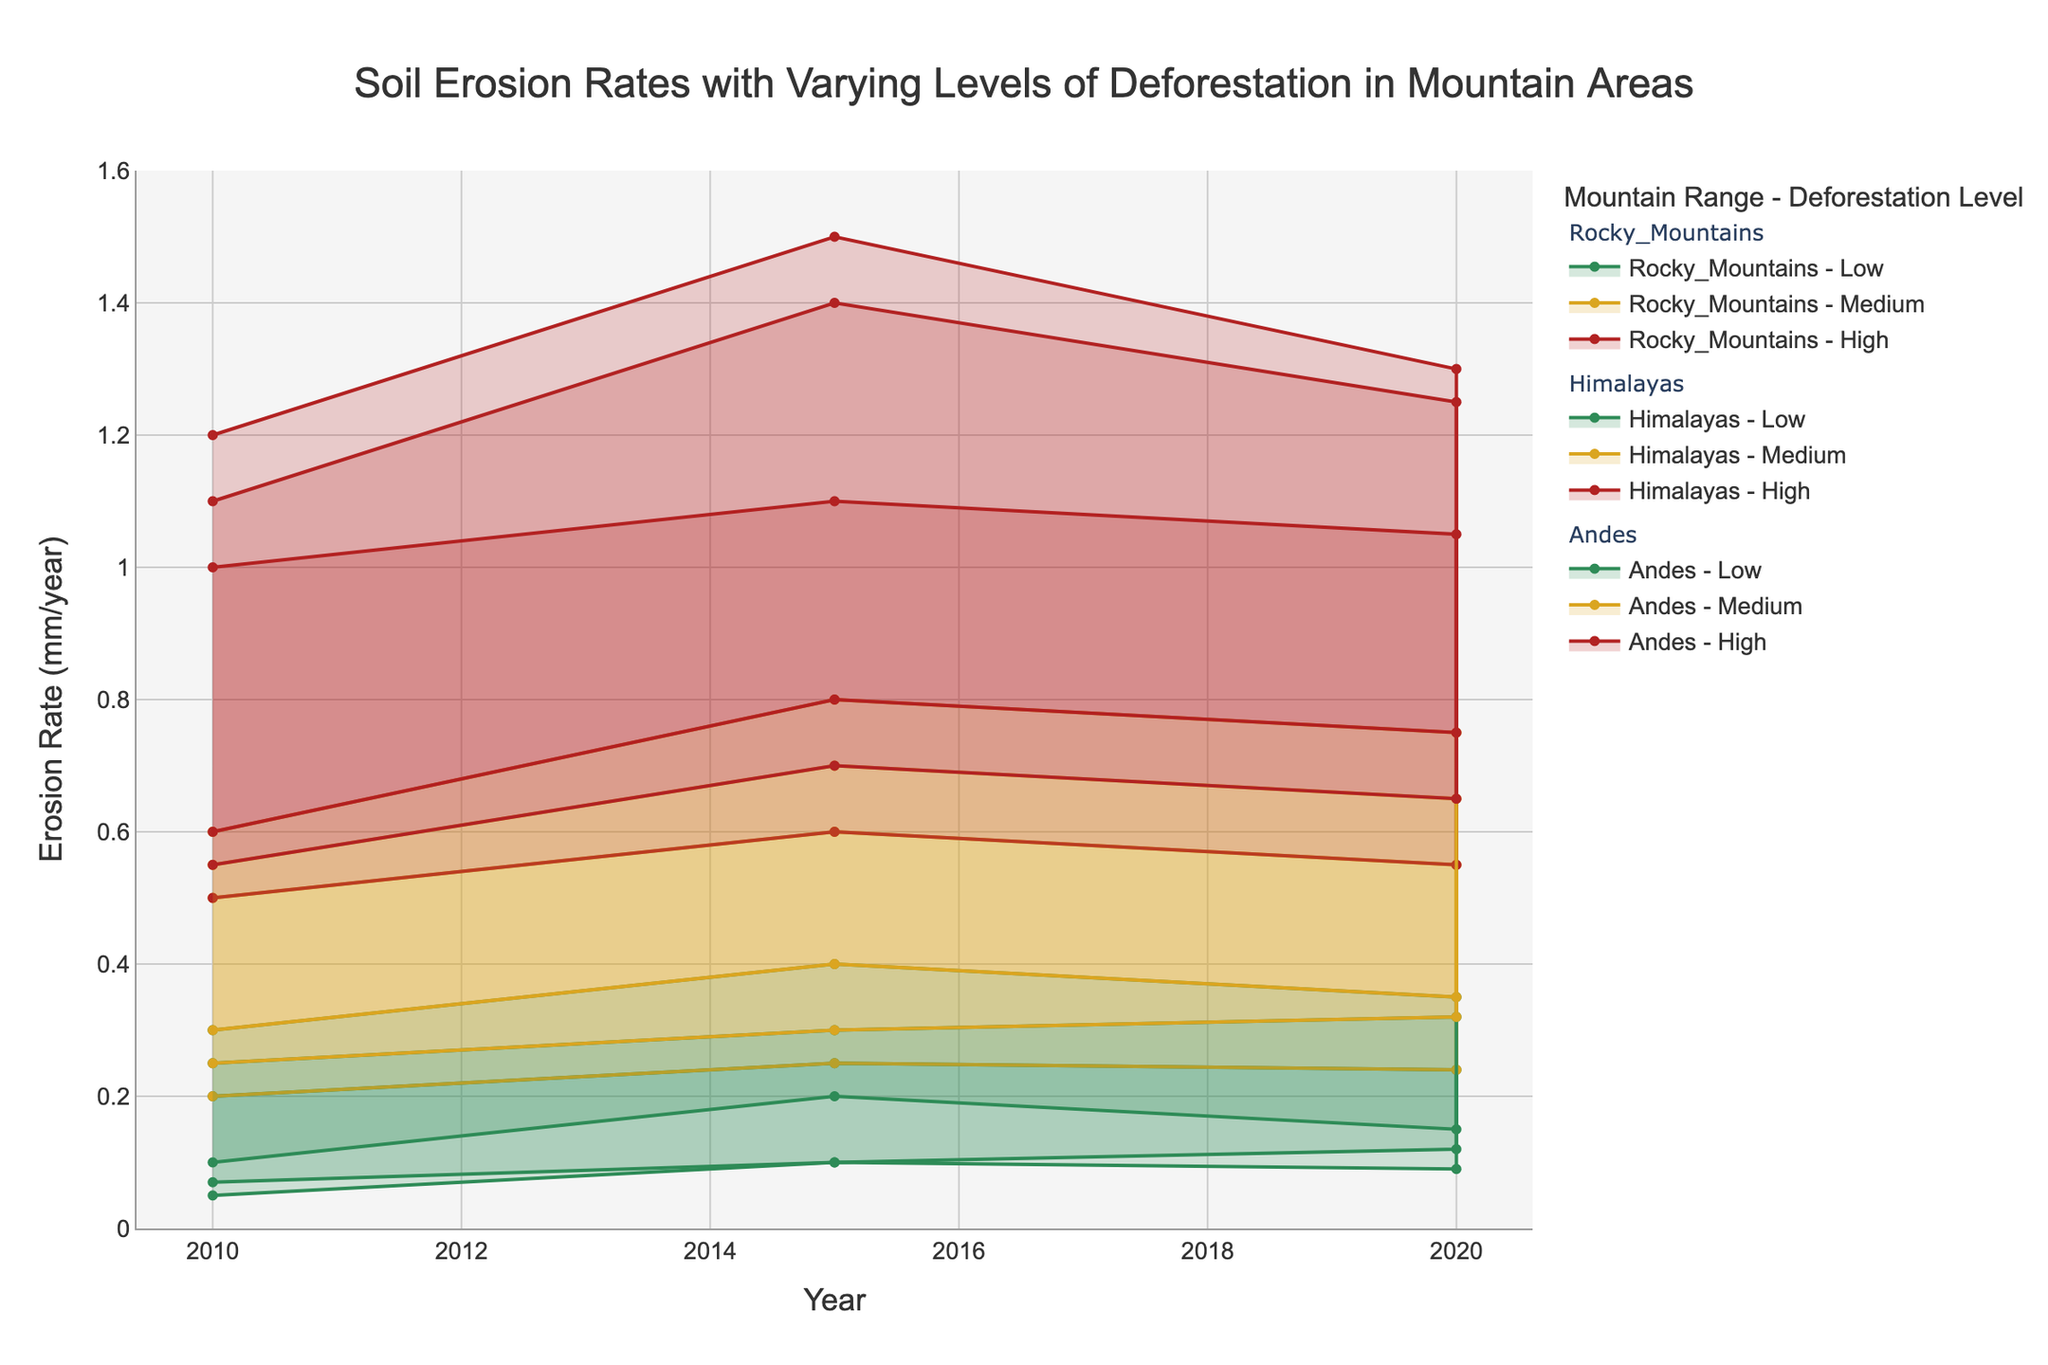What's the title of the plot? The plot title is usually located at the top center of the figure. By looking at this area, the title reads "Soil Erosion Rates with Varying Levels of Deforestation in Mountain Areas".
Answer: Soil Erosion Rates with Varying Levels of Deforestation in Mountain Areas Which range has the highest erosion rate in 2020 for the Andes with high deforestation? By examining the plot for 2020 and focusing on the Andes with high deforestation, the upper range erosion rate touches 1.25 mm/year.
Answer: 1.25 mm/year What is the lowest erosion rate for the Himalayas with low deforestation in 2010? Locate the Himalayas with low deforestation level for the year 2010 and check the lower bound of the erosion rate range, which is 0.05 mm/year.
Answer: 0.05 mm/year How does the upper range erosion rate for the Andes with medium deforestation in 2015 compare to the same in 2020? Check the upper range for medium deforestation levels in the Andes for both years. In 2015, it is 0.7 mm/year and in 2020, it is 0.65 mm/year. Thus, the rate decreased.
Answer: Decreased What is the average of the upper range erosion rates for the Rocky Mountains with low deforestation from 2010 to 2020? The upper range erosion rates for the Rocky Mountains with low deforestation are 0.3 (2010), 0.4 (2015), and 0.35 (2020). Summing these gives 0.3 + 0.4 + 0.35 = 1.05 and dividing by 3 gives the average: 1.05/3 = 0.35 mm/year
Answer: 0.35 mm/year Which location has shown an increase in both the lower and upper ranges of erosion rates from 2010 to 2020 for all deforestation levels? By examining each location for the given years and levels, only the Rocky Mountains show an increase in both ranges for all levels: low (0.1 to 0.15), medium (0.3 to 0.35), and high (0.6 to 0.75) in lower ranges; low (0.3 to 0.35), medium (0.6 to 0.75), and high (1.2 to 1.3) in upper ranges.
Answer: Rocky Mountains Which of the studied mountain ranges showed the least impact of deforestation on soil erosion rates in 2020? By comparing the ranges for the year 2020, the Himalayas have the smallest difference between high and low deforestation levels in terms of erosion rates: low (0.09 to 0.24), high (0.55 to 1.05). The range difference for Himalayas is 0.31 (low) to 0.5 (high).
Answer: Himalayas What can be inferred about the trend of soil erosion rates between 2010 and 2020 for medium deforestation in the Andes? Looking specifically at medium deforestation levels in the Andes between 2010 and 2020, the lower range values are 0.25 (2010), 0.3 (2015), and 0.32 (2020). The upper range values are 0.55 (2010), 0.7 (2015), and 0.65 (2020). This indicates an overall increasing trend in the lower range and a non-linear trend in the upper range, peaking in 2015.
Answer: Increasing trend in lower range, non-linear in upper range 